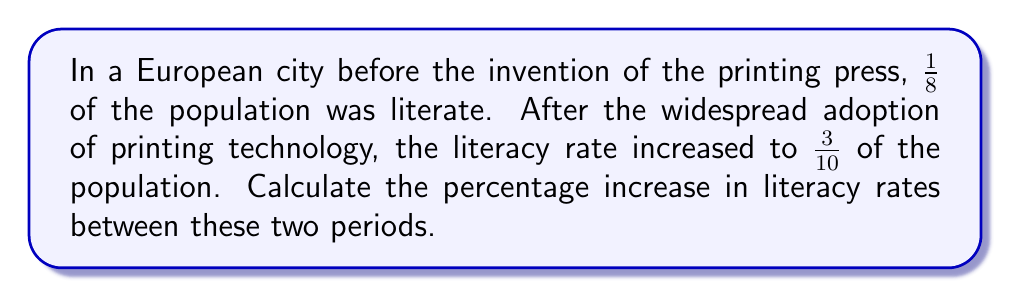Show me your answer to this math problem. To calculate the percentage increase in literacy rates, we need to follow these steps:

1. Calculate the difference between the two fractions:
   $$\frac{3}{10} - \frac{1}{8}$$

2. To subtract fractions with different denominators, we need to find a common denominator. The least common multiple of 8 and 10 is 40:
   $$\frac{3}{10} = \frac{3 \times 4}{10 \times 4} = \frac{12}{40}$$
   $$\frac{1}{8} = \frac{1 \times 5}{8 \times 5} = \frac{5}{40}$$

3. Now we can subtract:
   $$\frac{12}{40} - \frac{5}{40} = \frac{7}{40}$$

4. This fraction represents the absolute increase in literacy rate. To calculate the percentage increase, we need to divide this increase by the original rate and multiply by 100:
   $$\text{Percentage increase} = \frac{\text{Increase}}{\text{Original}} \times 100\%$$
   $$= \frac{\frac{7}{40}}{\frac{1}{8}} \times 100\%$$

5. To divide fractions, we multiply by the reciprocal:
   $$= \frac{7}{40} \times \frac{8}{1} \times 100\%$$
   $$= \frac{7 \times 8}{40} \times 100\%$$
   $$= \frac{56}{40} \times 100\%$$
   $$= 1.4 \times 100\%$$
   $$= 140\%$$

Therefore, the percentage increase in literacy rates is 140%.
Answer: 140% 